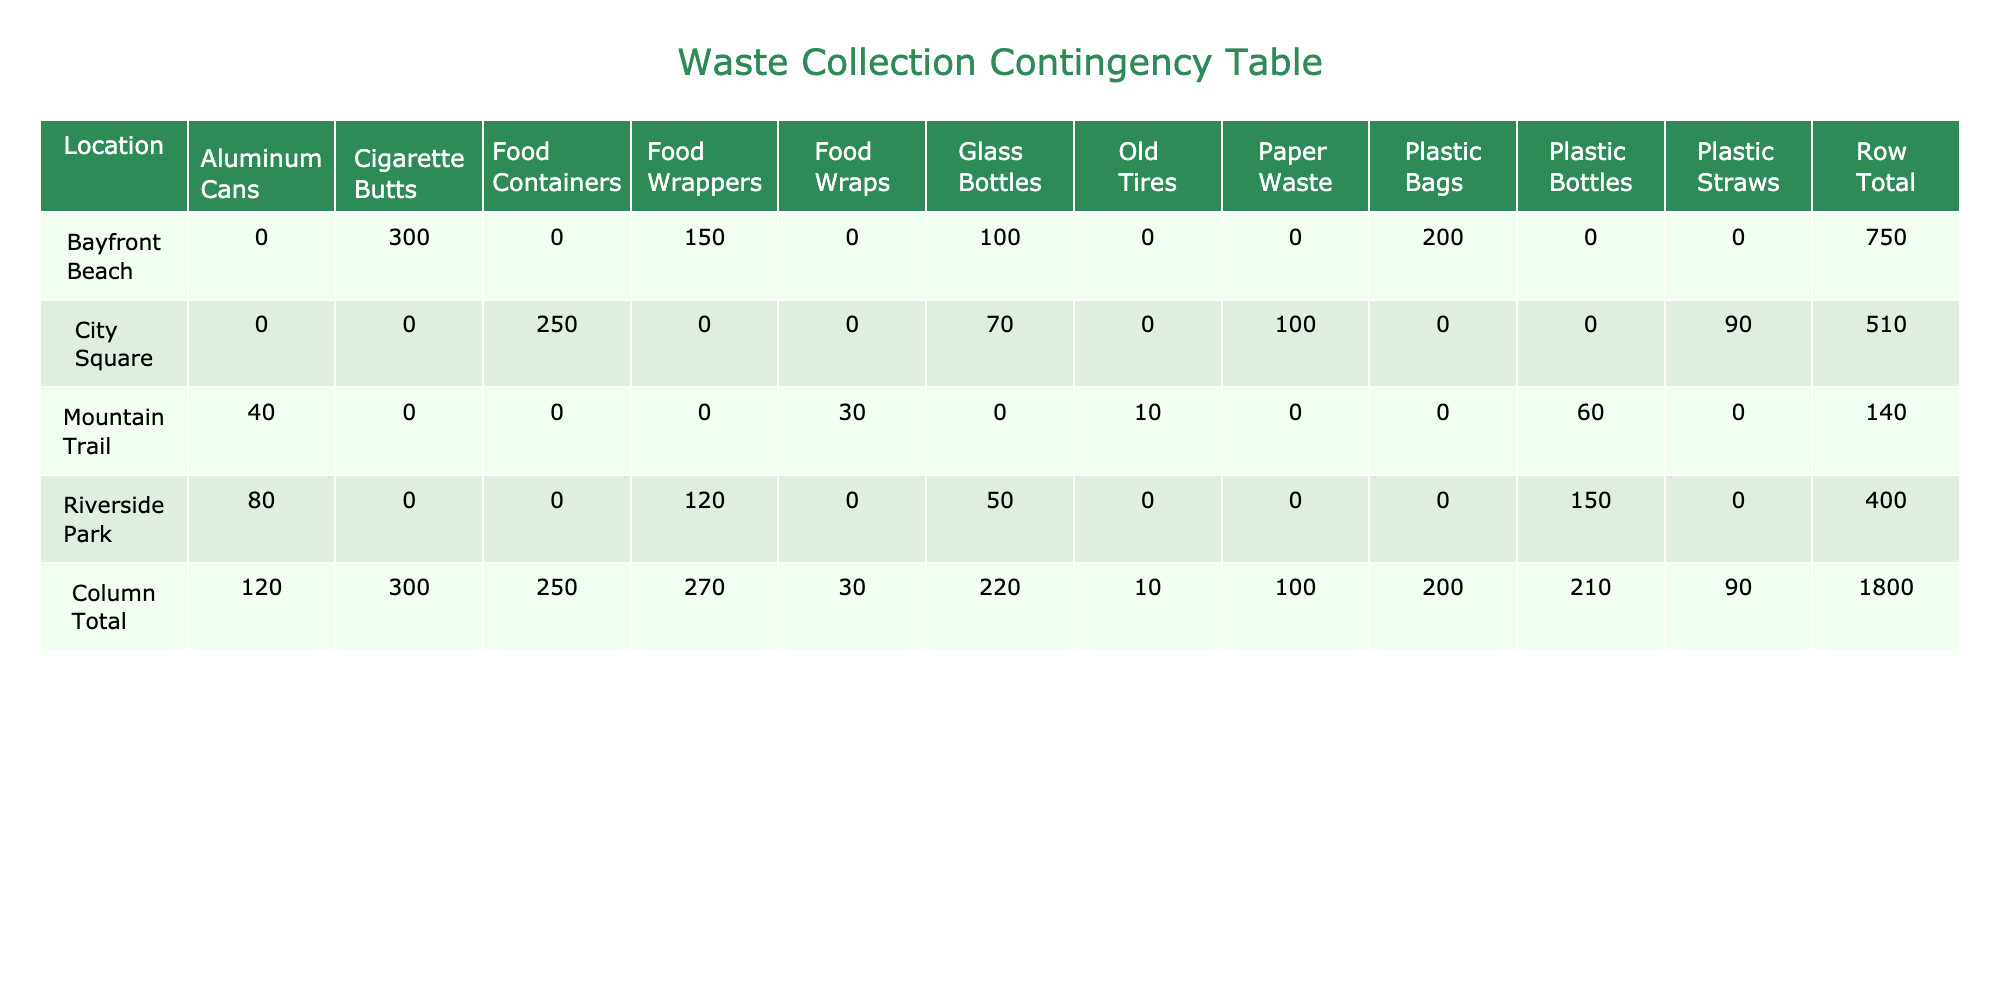What is the total quantity of waste collected at City Square? To find the total quantity of waste collected at City Square, I look for the 'Row Total' for City Square in the table. The quantities listed for City Square are 250 (Food Containers), 90 (Plastic Straws), 70 (Glass Bottles), and 100 (Paper Waste). Summing these values gives 250 + 90 + 70 + 100 = 510.
Answer: 510 Which location had the highest number of Plastic Bags collected? I check the entries under the "Plastic Bags" waste type and find that only Bayfront Beach has a quantity listed, which is 200. There are no entries for other locations, so Bayfront Beach is confirmed to have the highest quantity.
Answer: Bayfront Beach Is there any location where no Glass Bottles were collected? By reviewing the table, I notice that both Mountain Trail and Riverside Park have quantities of Glass Bottles collected (50 and 0 respectively), while City Square has 70. However, since Mountain Trail has a zero count for Glass Bottles, this confirms that yes, there is a location with zero collected quantity.
Answer: Yes What is the total amount of Food Wrappers collected across all locations? To find the total amount of Food Wrappers, I look at the quantities listed for this waste type. Riverside Park collected 120, Bayfront Beach collected 150, and Mountain Trail collected 30. Adding these values together yields 120 + 150 + 30 = 300.
Answer: 300 How many more Cigarette Butts were collected at Bayfront Beach compared to Old Tires at Mountain Trail? First, I take note that Bayfront Beach had 300 Cigarette Butts collected, while Mountain Trail had 10 Old Tires. Calculating the difference means subtracting Old Tires from Cigarette Butts: 300 - 10 = 290. Thus, 290 more Cigarette Butts were collected at Bayfront Beach compared to Old Tires at Mountain Trail.
Answer: 290 Which waste type had the lowest total quantity collected overall, and what was that quantity? I will sum the quantities for each waste type across all locations: Plastic Bottles (150 + 60), Aluminum Cans (80 + 40), Food Wrappers (120 + 150 + 30), Glass Bottles (50 + 100 + 70), Plastic Bags (200), Cigarette Butts (300), Food Containers (250), Plastic Straws (90), Paper Waste (100), and Old Tires (10). The totals are: Plastic Bottles (210), Aluminum Cans (120), Food Wrappers (300), Glass Bottles (220), Plastic Bags (200), Cigarette Butts (300), Food Containers (250), Plastic Straws (90), Paper Waste (100), and Old Tires (10). The lowest total is for Old Tires, with a sum of 10.
Answer: Old Tires, 10 